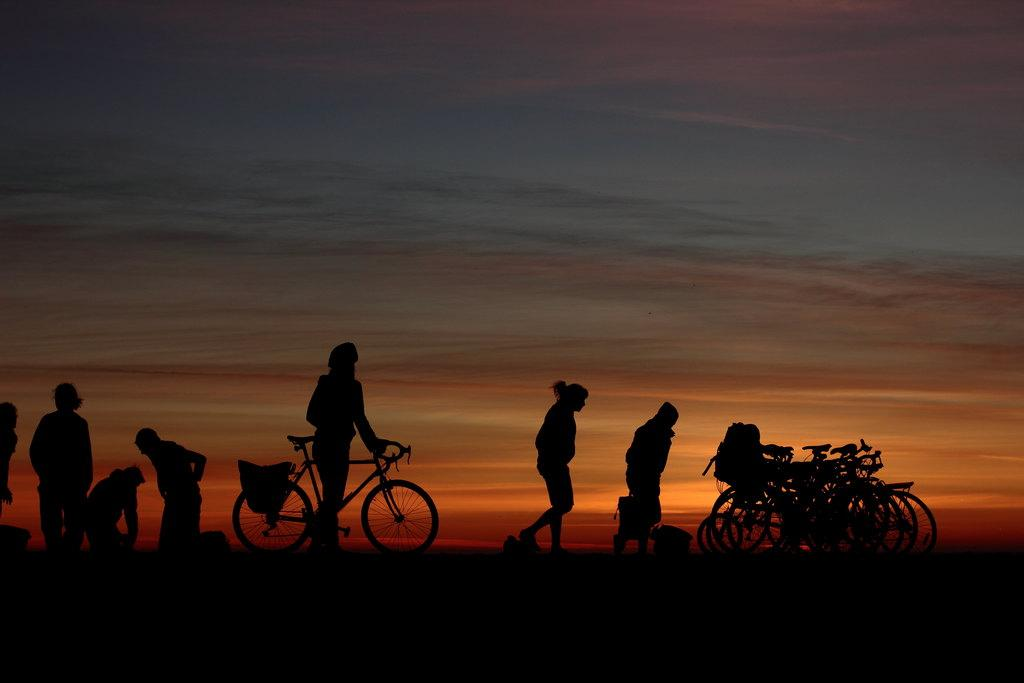What can be seen on the ground in the image? There are reflections of people and bicycles on the ground. What is the color of the sky in the image? The sky is dark in the image. What is happening to the sun in the image? The sun is setting in the image. How many apples can be seen on the ground in the image? There are no apples present in the image; it features reflections of people and bicycles on the ground. What type of trucks are visible in the image? There are no trucks present in the image. 